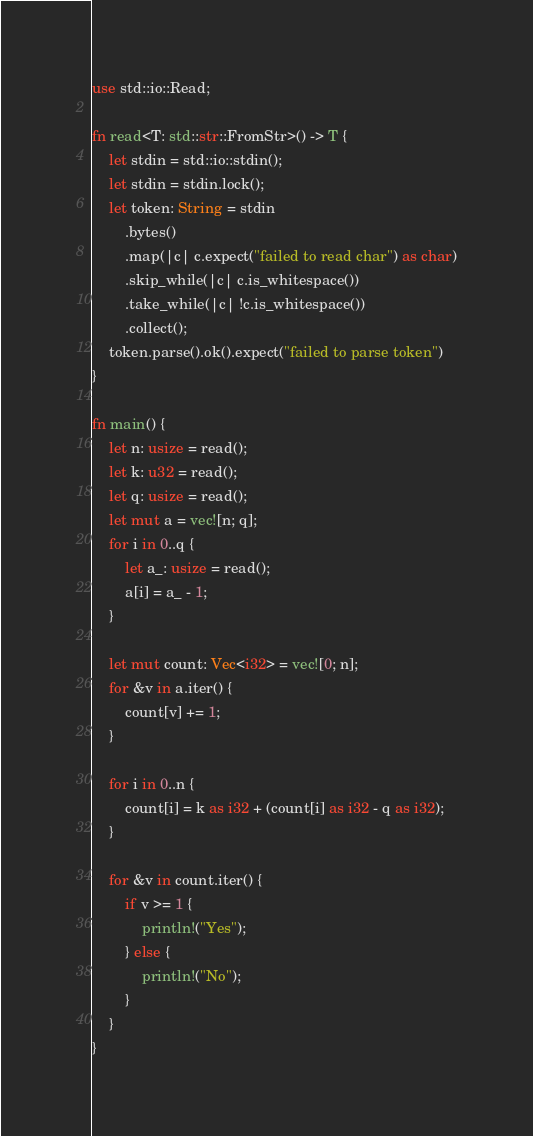Convert code to text. <code><loc_0><loc_0><loc_500><loc_500><_Rust_>use std::io::Read;

fn read<T: std::str::FromStr>() -> T {
    let stdin = std::io::stdin();
    let stdin = stdin.lock();
    let token: String = stdin
        .bytes()
        .map(|c| c.expect("failed to read char") as char)
        .skip_while(|c| c.is_whitespace())
        .take_while(|c| !c.is_whitespace())
        .collect();
    token.parse().ok().expect("failed to parse token")
}

fn main() {
    let n: usize = read();
    let k: u32 = read();
    let q: usize = read();
    let mut a = vec![n; q];
    for i in 0..q {
        let a_: usize = read();
        a[i] = a_ - 1;
    }

    let mut count: Vec<i32> = vec![0; n];
    for &v in a.iter() {
        count[v] += 1;
    }

    for i in 0..n {
        count[i] = k as i32 + (count[i] as i32 - q as i32);
    }

    for &v in count.iter() {
        if v >= 1 {
            println!("Yes");
        } else {
            println!("No");
        }
    }
}
</code> 